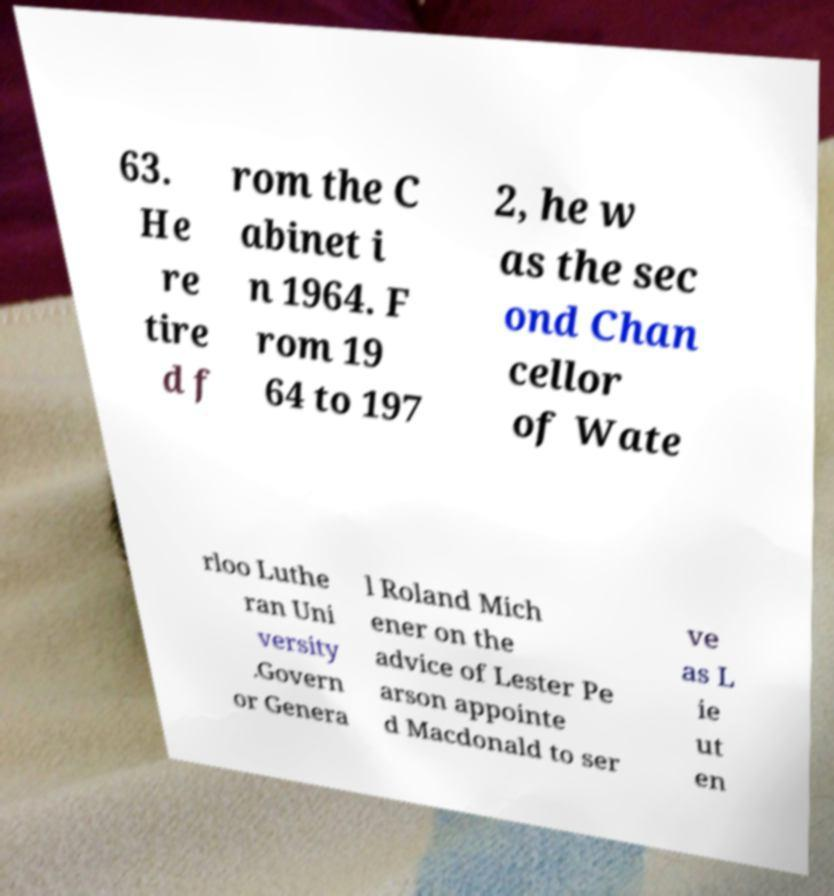Can you read and provide the text displayed in the image?This photo seems to have some interesting text. Can you extract and type it out for me? 63. He re tire d f rom the C abinet i n 1964. F rom 19 64 to 197 2, he w as the sec ond Chan cellor of Wate rloo Luthe ran Uni versity .Govern or Genera l Roland Mich ener on the advice of Lester Pe arson appointe d Macdonald to ser ve as L ie ut en 